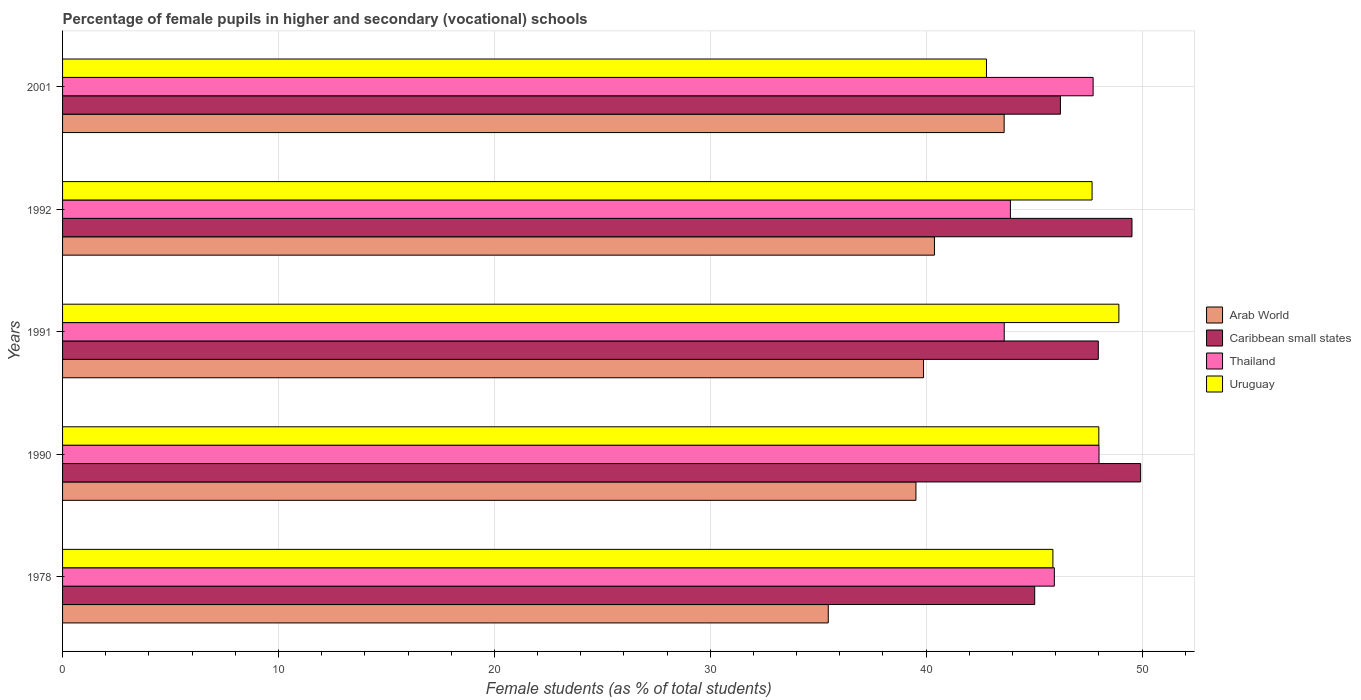Are the number of bars per tick equal to the number of legend labels?
Provide a short and direct response. Yes. Are the number of bars on each tick of the Y-axis equal?
Your answer should be very brief. Yes. How many bars are there on the 3rd tick from the bottom?
Provide a short and direct response. 4. What is the label of the 2nd group of bars from the top?
Provide a short and direct response. 1992. In how many cases, is the number of bars for a given year not equal to the number of legend labels?
Offer a very short reply. 0. What is the percentage of female pupils in higher and secondary schools in Uruguay in 1978?
Keep it short and to the point. 45.87. Across all years, what is the maximum percentage of female pupils in higher and secondary schools in Caribbean small states?
Give a very brief answer. 49.93. Across all years, what is the minimum percentage of female pupils in higher and secondary schools in Arab World?
Give a very brief answer. 35.47. In which year was the percentage of female pupils in higher and secondary schools in Arab World maximum?
Your answer should be very brief. 2001. In which year was the percentage of female pupils in higher and secondary schools in Caribbean small states minimum?
Your answer should be very brief. 1978. What is the total percentage of female pupils in higher and secondary schools in Arab World in the graph?
Your response must be concise. 198.87. What is the difference between the percentage of female pupils in higher and secondary schools in Uruguay in 1978 and that in 1990?
Your answer should be very brief. -2.13. What is the difference between the percentage of female pupils in higher and secondary schools in Thailand in 1990 and the percentage of female pupils in higher and secondary schools in Uruguay in 1992?
Provide a succinct answer. 0.32. What is the average percentage of female pupils in higher and secondary schools in Uruguay per year?
Your answer should be very brief. 46.65. In the year 1990, what is the difference between the percentage of female pupils in higher and secondary schools in Uruguay and percentage of female pupils in higher and secondary schools in Thailand?
Your response must be concise. -0.01. In how many years, is the percentage of female pupils in higher and secondary schools in Arab World greater than 2 %?
Make the answer very short. 5. What is the ratio of the percentage of female pupils in higher and secondary schools in Uruguay in 1978 to that in 1991?
Ensure brevity in your answer.  0.94. What is the difference between the highest and the second highest percentage of female pupils in higher and secondary schools in Arab World?
Offer a terse response. 3.23. What is the difference between the highest and the lowest percentage of female pupils in higher and secondary schools in Thailand?
Offer a terse response. 4.39. Is the sum of the percentage of female pupils in higher and secondary schools in Uruguay in 1978 and 1992 greater than the maximum percentage of female pupils in higher and secondary schools in Arab World across all years?
Provide a succinct answer. Yes. Is it the case that in every year, the sum of the percentage of female pupils in higher and secondary schools in Thailand and percentage of female pupils in higher and secondary schools in Arab World is greater than the sum of percentage of female pupils in higher and secondary schools in Uruguay and percentage of female pupils in higher and secondary schools in Caribbean small states?
Keep it short and to the point. No. What does the 1st bar from the top in 1990 represents?
Provide a short and direct response. Uruguay. What does the 4th bar from the bottom in 1990 represents?
Your response must be concise. Uruguay. Are the values on the major ticks of X-axis written in scientific E-notation?
Provide a succinct answer. No. Does the graph contain any zero values?
Make the answer very short. No. Where does the legend appear in the graph?
Ensure brevity in your answer.  Center right. How are the legend labels stacked?
Make the answer very short. Vertical. What is the title of the graph?
Ensure brevity in your answer.  Percentage of female pupils in higher and secondary (vocational) schools. What is the label or title of the X-axis?
Give a very brief answer. Female students (as % of total students). What is the label or title of the Y-axis?
Offer a terse response. Years. What is the Female students (as % of total students) of Arab World in 1978?
Offer a terse response. 35.47. What is the Female students (as % of total students) in Caribbean small states in 1978?
Provide a succinct answer. 45.03. What is the Female students (as % of total students) in Thailand in 1978?
Your response must be concise. 45.94. What is the Female students (as % of total students) in Uruguay in 1978?
Offer a terse response. 45.87. What is the Female students (as % of total students) in Arab World in 1990?
Your answer should be compact. 39.53. What is the Female students (as % of total students) in Caribbean small states in 1990?
Keep it short and to the point. 49.93. What is the Female students (as % of total students) in Thailand in 1990?
Keep it short and to the point. 48.01. What is the Female students (as % of total students) of Uruguay in 1990?
Offer a terse response. 48. What is the Female students (as % of total students) of Arab World in 1991?
Provide a short and direct response. 39.88. What is the Female students (as % of total students) in Caribbean small states in 1991?
Your response must be concise. 47.97. What is the Female students (as % of total students) of Thailand in 1991?
Offer a very short reply. 43.62. What is the Female students (as % of total students) of Uruguay in 1991?
Your answer should be very brief. 48.93. What is the Female students (as % of total students) in Arab World in 1992?
Keep it short and to the point. 40.38. What is the Female students (as % of total students) in Caribbean small states in 1992?
Your answer should be compact. 49.53. What is the Female students (as % of total students) in Thailand in 1992?
Provide a succinct answer. 43.9. What is the Female students (as % of total students) in Uruguay in 1992?
Keep it short and to the point. 47.68. What is the Female students (as % of total students) in Arab World in 2001?
Your answer should be compact. 43.61. What is the Female students (as % of total students) in Caribbean small states in 2001?
Give a very brief answer. 46.22. What is the Female students (as % of total students) of Thailand in 2001?
Ensure brevity in your answer.  47.73. What is the Female students (as % of total students) of Uruguay in 2001?
Your answer should be compact. 42.79. Across all years, what is the maximum Female students (as % of total students) in Arab World?
Give a very brief answer. 43.61. Across all years, what is the maximum Female students (as % of total students) in Caribbean small states?
Provide a succinct answer. 49.93. Across all years, what is the maximum Female students (as % of total students) in Thailand?
Ensure brevity in your answer.  48.01. Across all years, what is the maximum Female students (as % of total students) in Uruguay?
Keep it short and to the point. 48.93. Across all years, what is the minimum Female students (as % of total students) in Arab World?
Ensure brevity in your answer.  35.47. Across all years, what is the minimum Female students (as % of total students) in Caribbean small states?
Your answer should be compact. 45.03. Across all years, what is the minimum Female students (as % of total students) of Thailand?
Ensure brevity in your answer.  43.62. Across all years, what is the minimum Female students (as % of total students) in Uruguay?
Ensure brevity in your answer.  42.79. What is the total Female students (as % of total students) in Arab World in the graph?
Give a very brief answer. 198.87. What is the total Female students (as % of total students) of Caribbean small states in the graph?
Provide a short and direct response. 238.69. What is the total Female students (as % of total students) of Thailand in the graph?
Make the answer very short. 229.2. What is the total Female students (as % of total students) of Uruguay in the graph?
Offer a terse response. 233.27. What is the difference between the Female students (as % of total students) of Arab World in 1978 and that in 1990?
Your answer should be compact. -4.06. What is the difference between the Female students (as % of total students) in Caribbean small states in 1978 and that in 1990?
Keep it short and to the point. -4.91. What is the difference between the Female students (as % of total students) in Thailand in 1978 and that in 1990?
Ensure brevity in your answer.  -2.07. What is the difference between the Female students (as % of total students) of Uruguay in 1978 and that in 1990?
Your answer should be compact. -2.13. What is the difference between the Female students (as % of total students) of Arab World in 1978 and that in 1991?
Your response must be concise. -4.41. What is the difference between the Female students (as % of total students) of Caribbean small states in 1978 and that in 1991?
Ensure brevity in your answer.  -2.94. What is the difference between the Female students (as % of total students) in Thailand in 1978 and that in 1991?
Your response must be concise. 2.32. What is the difference between the Female students (as % of total students) of Uruguay in 1978 and that in 1991?
Ensure brevity in your answer.  -3.06. What is the difference between the Female students (as % of total students) in Arab World in 1978 and that in 1992?
Offer a terse response. -4.92. What is the difference between the Female students (as % of total students) of Caribbean small states in 1978 and that in 1992?
Ensure brevity in your answer.  -4.51. What is the difference between the Female students (as % of total students) of Thailand in 1978 and that in 1992?
Keep it short and to the point. 2.04. What is the difference between the Female students (as % of total students) of Uruguay in 1978 and that in 1992?
Provide a succinct answer. -1.81. What is the difference between the Female students (as % of total students) of Arab World in 1978 and that in 2001?
Your answer should be very brief. -8.15. What is the difference between the Female students (as % of total students) in Caribbean small states in 1978 and that in 2001?
Provide a succinct answer. -1.19. What is the difference between the Female students (as % of total students) in Thailand in 1978 and that in 2001?
Provide a succinct answer. -1.8. What is the difference between the Female students (as % of total students) in Uruguay in 1978 and that in 2001?
Offer a terse response. 3.08. What is the difference between the Female students (as % of total students) of Arab World in 1990 and that in 1991?
Your answer should be compact. -0.35. What is the difference between the Female students (as % of total students) of Caribbean small states in 1990 and that in 1991?
Provide a short and direct response. 1.96. What is the difference between the Female students (as % of total students) of Thailand in 1990 and that in 1991?
Provide a short and direct response. 4.39. What is the difference between the Female students (as % of total students) in Uruguay in 1990 and that in 1991?
Keep it short and to the point. -0.93. What is the difference between the Female students (as % of total students) in Arab World in 1990 and that in 1992?
Make the answer very short. -0.86. What is the difference between the Female students (as % of total students) of Caribbean small states in 1990 and that in 1992?
Offer a terse response. 0.4. What is the difference between the Female students (as % of total students) of Thailand in 1990 and that in 1992?
Your answer should be compact. 4.1. What is the difference between the Female students (as % of total students) in Uruguay in 1990 and that in 1992?
Provide a succinct answer. 0.31. What is the difference between the Female students (as % of total students) of Arab World in 1990 and that in 2001?
Your response must be concise. -4.09. What is the difference between the Female students (as % of total students) in Caribbean small states in 1990 and that in 2001?
Provide a short and direct response. 3.72. What is the difference between the Female students (as % of total students) in Thailand in 1990 and that in 2001?
Ensure brevity in your answer.  0.27. What is the difference between the Female students (as % of total students) of Uruguay in 1990 and that in 2001?
Provide a succinct answer. 5.2. What is the difference between the Female students (as % of total students) in Arab World in 1991 and that in 1992?
Your answer should be very brief. -0.51. What is the difference between the Female students (as % of total students) in Caribbean small states in 1991 and that in 1992?
Provide a succinct answer. -1.56. What is the difference between the Female students (as % of total students) in Thailand in 1991 and that in 1992?
Keep it short and to the point. -0.29. What is the difference between the Female students (as % of total students) in Uruguay in 1991 and that in 1992?
Provide a succinct answer. 1.24. What is the difference between the Female students (as % of total students) of Arab World in 1991 and that in 2001?
Offer a terse response. -3.73. What is the difference between the Female students (as % of total students) of Caribbean small states in 1991 and that in 2001?
Offer a very short reply. 1.75. What is the difference between the Female students (as % of total students) of Thailand in 1991 and that in 2001?
Your answer should be compact. -4.12. What is the difference between the Female students (as % of total students) of Uruguay in 1991 and that in 2001?
Your answer should be compact. 6.13. What is the difference between the Female students (as % of total students) in Arab World in 1992 and that in 2001?
Your response must be concise. -3.23. What is the difference between the Female students (as % of total students) in Caribbean small states in 1992 and that in 2001?
Provide a succinct answer. 3.32. What is the difference between the Female students (as % of total students) of Thailand in 1992 and that in 2001?
Offer a very short reply. -3.83. What is the difference between the Female students (as % of total students) in Uruguay in 1992 and that in 2001?
Provide a short and direct response. 4.89. What is the difference between the Female students (as % of total students) of Arab World in 1978 and the Female students (as % of total students) of Caribbean small states in 1990?
Ensure brevity in your answer.  -14.47. What is the difference between the Female students (as % of total students) of Arab World in 1978 and the Female students (as % of total students) of Thailand in 1990?
Give a very brief answer. -12.54. What is the difference between the Female students (as % of total students) of Arab World in 1978 and the Female students (as % of total students) of Uruguay in 1990?
Provide a succinct answer. -12.53. What is the difference between the Female students (as % of total students) of Caribbean small states in 1978 and the Female students (as % of total students) of Thailand in 1990?
Keep it short and to the point. -2.98. What is the difference between the Female students (as % of total students) of Caribbean small states in 1978 and the Female students (as % of total students) of Uruguay in 1990?
Your answer should be very brief. -2.97. What is the difference between the Female students (as % of total students) of Thailand in 1978 and the Female students (as % of total students) of Uruguay in 1990?
Keep it short and to the point. -2.06. What is the difference between the Female students (as % of total students) of Arab World in 1978 and the Female students (as % of total students) of Caribbean small states in 1991?
Your answer should be very brief. -12.51. What is the difference between the Female students (as % of total students) in Arab World in 1978 and the Female students (as % of total students) in Thailand in 1991?
Offer a very short reply. -8.15. What is the difference between the Female students (as % of total students) of Arab World in 1978 and the Female students (as % of total students) of Uruguay in 1991?
Your response must be concise. -13.46. What is the difference between the Female students (as % of total students) in Caribbean small states in 1978 and the Female students (as % of total students) in Thailand in 1991?
Your answer should be very brief. 1.41. What is the difference between the Female students (as % of total students) in Caribbean small states in 1978 and the Female students (as % of total students) in Uruguay in 1991?
Keep it short and to the point. -3.9. What is the difference between the Female students (as % of total students) of Thailand in 1978 and the Female students (as % of total students) of Uruguay in 1991?
Your answer should be compact. -2.99. What is the difference between the Female students (as % of total students) in Arab World in 1978 and the Female students (as % of total students) in Caribbean small states in 1992?
Ensure brevity in your answer.  -14.07. What is the difference between the Female students (as % of total students) in Arab World in 1978 and the Female students (as % of total students) in Thailand in 1992?
Provide a succinct answer. -8.44. What is the difference between the Female students (as % of total students) of Arab World in 1978 and the Female students (as % of total students) of Uruguay in 1992?
Your answer should be compact. -12.22. What is the difference between the Female students (as % of total students) of Caribbean small states in 1978 and the Female students (as % of total students) of Thailand in 1992?
Provide a short and direct response. 1.13. What is the difference between the Female students (as % of total students) in Caribbean small states in 1978 and the Female students (as % of total students) in Uruguay in 1992?
Offer a terse response. -2.66. What is the difference between the Female students (as % of total students) of Thailand in 1978 and the Female students (as % of total students) of Uruguay in 1992?
Ensure brevity in your answer.  -1.75. What is the difference between the Female students (as % of total students) of Arab World in 1978 and the Female students (as % of total students) of Caribbean small states in 2001?
Keep it short and to the point. -10.75. What is the difference between the Female students (as % of total students) in Arab World in 1978 and the Female students (as % of total students) in Thailand in 2001?
Keep it short and to the point. -12.27. What is the difference between the Female students (as % of total students) in Arab World in 1978 and the Female students (as % of total students) in Uruguay in 2001?
Your answer should be compact. -7.33. What is the difference between the Female students (as % of total students) of Caribbean small states in 1978 and the Female students (as % of total students) of Thailand in 2001?
Your response must be concise. -2.71. What is the difference between the Female students (as % of total students) of Caribbean small states in 1978 and the Female students (as % of total students) of Uruguay in 2001?
Offer a terse response. 2.23. What is the difference between the Female students (as % of total students) in Thailand in 1978 and the Female students (as % of total students) in Uruguay in 2001?
Your response must be concise. 3.14. What is the difference between the Female students (as % of total students) of Arab World in 1990 and the Female students (as % of total students) of Caribbean small states in 1991?
Offer a terse response. -8.45. What is the difference between the Female students (as % of total students) in Arab World in 1990 and the Female students (as % of total students) in Thailand in 1991?
Make the answer very short. -4.09. What is the difference between the Female students (as % of total students) in Arab World in 1990 and the Female students (as % of total students) in Uruguay in 1991?
Offer a terse response. -9.4. What is the difference between the Female students (as % of total students) in Caribbean small states in 1990 and the Female students (as % of total students) in Thailand in 1991?
Offer a very short reply. 6.32. What is the difference between the Female students (as % of total students) of Caribbean small states in 1990 and the Female students (as % of total students) of Uruguay in 1991?
Give a very brief answer. 1.01. What is the difference between the Female students (as % of total students) of Thailand in 1990 and the Female students (as % of total students) of Uruguay in 1991?
Your answer should be compact. -0.92. What is the difference between the Female students (as % of total students) in Arab World in 1990 and the Female students (as % of total students) in Caribbean small states in 1992?
Ensure brevity in your answer.  -10.01. What is the difference between the Female students (as % of total students) in Arab World in 1990 and the Female students (as % of total students) in Thailand in 1992?
Give a very brief answer. -4.38. What is the difference between the Female students (as % of total students) of Arab World in 1990 and the Female students (as % of total students) of Uruguay in 1992?
Provide a succinct answer. -8.16. What is the difference between the Female students (as % of total students) in Caribbean small states in 1990 and the Female students (as % of total students) in Thailand in 1992?
Make the answer very short. 6.03. What is the difference between the Female students (as % of total students) of Caribbean small states in 1990 and the Female students (as % of total students) of Uruguay in 1992?
Provide a succinct answer. 2.25. What is the difference between the Female students (as % of total students) in Thailand in 1990 and the Female students (as % of total students) in Uruguay in 1992?
Give a very brief answer. 0.32. What is the difference between the Female students (as % of total students) in Arab World in 1990 and the Female students (as % of total students) in Caribbean small states in 2001?
Give a very brief answer. -6.69. What is the difference between the Female students (as % of total students) of Arab World in 1990 and the Female students (as % of total students) of Thailand in 2001?
Your answer should be compact. -8.21. What is the difference between the Female students (as % of total students) of Arab World in 1990 and the Female students (as % of total students) of Uruguay in 2001?
Ensure brevity in your answer.  -3.27. What is the difference between the Female students (as % of total students) of Caribbean small states in 1990 and the Female students (as % of total students) of Thailand in 2001?
Offer a very short reply. 2.2. What is the difference between the Female students (as % of total students) of Caribbean small states in 1990 and the Female students (as % of total students) of Uruguay in 2001?
Make the answer very short. 7.14. What is the difference between the Female students (as % of total students) in Thailand in 1990 and the Female students (as % of total students) in Uruguay in 2001?
Provide a short and direct response. 5.21. What is the difference between the Female students (as % of total students) of Arab World in 1991 and the Female students (as % of total students) of Caribbean small states in 1992?
Keep it short and to the point. -9.66. What is the difference between the Female students (as % of total students) in Arab World in 1991 and the Female students (as % of total students) in Thailand in 1992?
Keep it short and to the point. -4.02. What is the difference between the Female students (as % of total students) of Arab World in 1991 and the Female students (as % of total students) of Uruguay in 1992?
Give a very brief answer. -7.81. What is the difference between the Female students (as % of total students) of Caribbean small states in 1991 and the Female students (as % of total students) of Thailand in 1992?
Provide a short and direct response. 4.07. What is the difference between the Female students (as % of total students) of Caribbean small states in 1991 and the Female students (as % of total students) of Uruguay in 1992?
Give a very brief answer. 0.29. What is the difference between the Female students (as % of total students) in Thailand in 1991 and the Female students (as % of total students) in Uruguay in 1992?
Ensure brevity in your answer.  -4.07. What is the difference between the Female students (as % of total students) of Arab World in 1991 and the Female students (as % of total students) of Caribbean small states in 2001?
Provide a short and direct response. -6.34. What is the difference between the Female students (as % of total students) of Arab World in 1991 and the Female students (as % of total students) of Thailand in 2001?
Give a very brief answer. -7.86. What is the difference between the Female students (as % of total students) in Arab World in 1991 and the Female students (as % of total students) in Uruguay in 2001?
Provide a succinct answer. -2.92. What is the difference between the Female students (as % of total students) in Caribbean small states in 1991 and the Female students (as % of total students) in Thailand in 2001?
Ensure brevity in your answer.  0.24. What is the difference between the Female students (as % of total students) of Caribbean small states in 1991 and the Female students (as % of total students) of Uruguay in 2001?
Provide a succinct answer. 5.18. What is the difference between the Female students (as % of total students) of Thailand in 1991 and the Female students (as % of total students) of Uruguay in 2001?
Offer a very short reply. 0.82. What is the difference between the Female students (as % of total students) in Arab World in 1992 and the Female students (as % of total students) in Caribbean small states in 2001?
Ensure brevity in your answer.  -5.83. What is the difference between the Female students (as % of total students) of Arab World in 1992 and the Female students (as % of total students) of Thailand in 2001?
Your response must be concise. -7.35. What is the difference between the Female students (as % of total students) of Arab World in 1992 and the Female students (as % of total students) of Uruguay in 2001?
Your answer should be compact. -2.41. What is the difference between the Female students (as % of total students) of Caribbean small states in 1992 and the Female students (as % of total students) of Thailand in 2001?
Ensure brevity in your answer.  1.8. What is the difference between the Female students (as % of total students) in Caribbean small states in 1992 and the Female students (as % of total students) in Uruguay in 2001?
Your answer should be very brief. 6.74. What is the difference between the Female students (as % of total students) in Thailand in 1992 and the Female students (as % of total students) in Uruguay in 2001?
Offer a very short reply. 1.11. What is the average Female students (as % of total students) in Arab World per year?
Give a very brief answer. 39.77. What is the average Female students (as % of total students) in Caribbean small states per year?
Give a very brief answer. 47.74. What is the average Female students (as % of total students) of Thailand per year?
Give a very brief answer. 45.84. What is the average Female students (as % of total students) of Uruguay per year?
Give a very brief answer. 46.65. In the year 1978, what is the difference between the Female students (as % of total students) of Arab World and Female students (as % of total students) of Caribbean small states?
Provide a short and direct response. -9.56. In the year 1978, what is the difference between the Female students (as % of total students) of Arab World and Female students (as % of total students) of Thailand?
Ensure brevity in your answer.  -10.47. In the year 1978, what is the difference between the Female students (as % of total students) of Arab World and Female students (as % of total students) of Uruguay?
Your response must be concise. -10.4. In the year 1978, what is the difference between the Female students (as % of total students) in Caribbean small states and Female students (as % of total students) in Thailand?
Ensure brevity in your answer.  -0.91. In the year 1978, what is the difference between the Female students (as % of total students) in Caribbean small states and Female students (as % of total students) in Uruguay?
Your answer should be compact. -0.84. In the year 1978, what is the difference between the Female students (as % of total students) in Thailand and Female students (as % of total students) in Uruguay?
Ensure brevity in your answer.  0.07. In the year 1990, what is the difference between the Female students (as % of total students) in Arab World and Female students (as % of total students) in Caribbean small states?
Your answer should be very brief. -10.41. In the year 1990, what is the difference between the Female students (as % of total students) of Arab World and Female students (as % of total students) of Thailand?
Provide a short and direct response. -8.48. In the year 1990, what is the difference between the Female students (as % of total students) of Arab World and Female students (as % of total students) of Uruguay?
Offer a terse response. -8.47. In the year 1990, what is the difference between the Female students (as % of total students) of Caribbean small states and Female students (as % of total students) of Thailand?
Make the answer very short. 1.93. In the year 1990, what is the difference between the Female students (as % of total students) in Caribbean small states and Female students (as % of total students) in Uruguay?
Keep it short and to the point. 1.94. In the year 1990, what is the difference between the Female students (as % of total students) in Thailand and Female students (as % of total students) in Uruguay?
Provide a succinct answer. 0.01. In the year 1991, what is the difference between the Female students (as % of total students) of Arab World and Female students (as % of total students) of Caribbean small states?
Keep it short and to the point. -8.09. In the year 1991, what is the difference between the Female students (as % of total students) of Arab World and Female students (as % of total students) of Thailand?
Ensure brevity in your answer.  -3.74. In the year 1991, what is the difference between the Female students (as % of total students) in Arab World and Female students (as % of total students) in Uruguay?
Provide a short and direct response. -9.05. In the year 1991, what is the difference between the Female students (as % of total students) of Caribbean small states and Female students (as % of total students) of Thailand?
Your answer should be very brief. 4.36. In the year 1991, what is the difference between the Female students (as % of total students) of Caribbean small states and Female students (as % of total students) of Uruguay?
Your answer should be compact. -0.95. In the year 1991, what is the difference between the Female students (as % of total students) of Thailand and Female students (as % of total students) of Uruguay?
Offer a terse response. -5.31. In the year 1992, what is the difference between the Female students (as % of total students) of Arab World and Female students (as % of total students) of Caribbean small states?
Provide a short and direct response. -9.15. In the year 1992, what is the difference between the Female students (as % of total students) in Arab World and Female students (as % of total students) in Thailand?
Give a very brief answer. -3.52. In the year 1992, what is the difference between the Female students (as % of total students) of Arab World and Female students (as % of total students) of Uruguay?
Offer a very short reply. -7.3. In the year 1992, what is the difference between the Female students (as % of total students) of Caribbean small states and Female students (as % of total students) of Thailand?
Give a very brief answer. 5.63. In the year 1992, what is the difference between the Female students (as % of total students) in Caribbean small states and Female students (as % of total students) in Uruguay?
Provide a short and direct response. 1.85. In the year 1992, what is the difference between the Female students (as % of total students) of Thailand and Female students (as % of total students) of Uruguay?
Your answer should be very brief. -3.78. In the year 2001, what is the difference between the Female students (as % of total students) of Arab World and Female students (as % of total students) of Caribbean small states?
Give a very brief answer. -2.61. In the year 2001, what is the difference between the Female students (as % of total students) of Arab World and Female students (as % of total students) of Thailand?
Your answer should be very brief. -4.12. In the year 2001, what is the difference between the Female students (as % of total students) of Arab World and Female students (as % of total students) of Uruguay?
Provide a short and direct response. 0.82. In the year 2001, what is the difference between the Female students (as % of total students) of Caribbean small states and Female students (as % of total students) of Thailand?
Offer a very short reply. -1.52. In the year 2001, what is the difference between the Female students (as % of total students) of Caribbean small states and Female students (as % of total students) of Uruguay?
Your answer should be compact. 3.42. In the year 2001, what is the difference between the Female students (as % of total students) of Thailand and Female students (as % of total students) of Uruguay?
Your answer should be compact. 4.94. What is the ratio of the Female students (as % of total students) of Arab World in 1978 to that in 1990?
Your response must be concise. 0.9. What is the ratio of the Female students (as % of total students) of Caribbean small states in 1978 to that in 1990?
Ensure brevity in your answer.  0.9. What is the ratio of the Female students (as % of total students) in Thailand in 1978 to that in 1990?
Your answer should be very brief. 0.96. What is the ratio of the Female students (as % of total students) in Uruguay in 1978 to that in 1990?
Ensure brevity in your answer.  0.96. What is the ratio of the Female students (as % of total students) in Arab World in 1978 to that in 1991?
Provide a succinct answer. 0.89. What is the ratio of the Female students (as % of total students) of Caribbean small states in 1978 to that in 1991?
Ensure brevity in your answer.  0.94. What is the ratio of the Female students (as % of total students) in Thailand in 1978 to that in 1991?
Your response must be concise. 1.05. What is the ratio of the Female students (as % of total students) in Uruguay in 1978 to that in 1991?
Your answer should be very brief. 0.94. What is the ratio of the Female students (as % of total students) of Arab World in 1978 to that in 1992?
Keep it short and to the point. 0.88. What is the ratio of the Female students (as % of total students) of Caribbean small states in 1978 to that in 1992?
Your response must be concise. 0.91. What is the ratio of the Female students (as % of total students) of Thailand in 1978 to that in 1992?
Your answer should be compact. 1.05. What is the ratio of the Female students (as % of total students) of Arab World in 1978 to that in 2001?
Keep it short and to the point. 0.81. What is the ratio of the Female students (as % of total students) of Caribbean small states in 1978 to that in 2001?
Your answer should be very brief. 0.97. What is the ratio of the Female students (as % of total students) of Thailand in 1978 to that in 2001?
Make the answer very short. 0.96. What is the ratio of the Female students (as % of total students) in Uruguay in 1978 to that in 2001?
Provide a short and direct response. 1.07. What is the ratio of the Female students (as % of total students) of Caribbean small states in 1990 to that in 1991?
Ensure brevity in your answer.  1.04. What is the ratio of the Female students (as % of total students) in Thailand in 1990 to that in 1991?
Ensure brevity in your answer.  1.1. What is the ratio of the Female students (as % of total students) in Uruguay in 1990 to that in 1991?
Your answer should be very brief. 0.98. What is the ratio of the Female students (as % of total students) of Arab World in 1990 to that in 1992?
Keep it short and to the point. 0.98. What is the ratio of the Female students (as % of total students) of Thailand in 1990 to that in 1992?
Offer a terse response. 1.09. What is the ratio of the Female students (as % of total students) in Uruguay in 1990 to that in 1992?
Offer a very short reply. 1.01. What is the ratio of the Female students (as % of total students) of Arab World in 1990 to that in 2001?
Ensure brevity in your answer.  0.91. What is the ratio of the Female students (as % of total students) in Caribbean small states in 1990 to that in 2001?
Your answer should be very brief. 1.08. What is the ratio of the Female students (as % of total students) in Thailand in 1990 to that in 2001?
Your response must be concise. 1.01. What is the ratio of the Female students (as % of total students) in Uruguay in 1990 to that in 2001?
Provide a succinct answer. 1.12. What is the ratio of the Female students (as % of total students) in Arab World in 1991 to that in 1992?
Offer a terse response. 0.99. What is the ratio of the Female students (as % of total students) of Caribbean small states in 1991 to that in 1992?
Your answer should be compact. 0.97. What is the ratio of the Female students (as % of total students) in Uruguay in 1991 to that in 1992?
Ensure brevity in your answer.  1.03. What is the ratio of the Female students (as % of total students) in Arab World in 1991 to that in 2001?
Offer a terse response. 0.91. What is the ratio of the Female students (as % of total students) in Caribbean small states in 1991 to that in 2001?
Provide a succinct answer. 1.04. What is the ratio of the Female students (as % of total students) of Thailand in 1991 to that in 2001?
Offer a terse response. 0.91. What is the ratio of the Female students (as % of total students) of Uruguay in 1991 to that in 2001?
Your answer should be compact. 1.14. What is the ratio of the Female students (as % of total students) of Arab World in 1992 to that in 2001?
Provide a short and direct response. 0.93. What is the ratio of the Female students (as % of total students) of Caribbean small states in 1992 to that in 2001?
Provide a short and direct response. 1.07. What is the ratio of the Female students (as % of total students) in Thailand in 1992 to that in 2001?
Your answer should be very brief. 0.92. What is the ratio of the Female students (as % of total students) in Uruguay in 1992 to that in 2001?
Provide a succinct answer. 1.11. What is the difference between the highest and the second highest Female students (as % of total students) in Arab World?
Ensure brevity in your answer.  3.23. What is the difference between the highest and the second highest Female students (as % of total students) in Caribbean small states?
Keep it short and to the point. 0.4. What is the difference between the highest and the second highest Female students (as % of total students) in Thailand?
Ensure brevity in your answer.  0.27. What is the difference between the highest and the lowest Female students (as % of total students) in Arab World?
Offer a very short reply. 8.15. What is the difference between the highest and the lowest Female students (as % of total students) in Caribbean small states?
Give a very brief answer. 4.91. What is the difference between the highest and the lowest Female students (as % of total students) of Thailand?
Offer a very short reply. 4.39. What is the difference between the highest and the lowest Female students (as % of total students) of Uruguay?
Offer a very short reply. 6.13. 